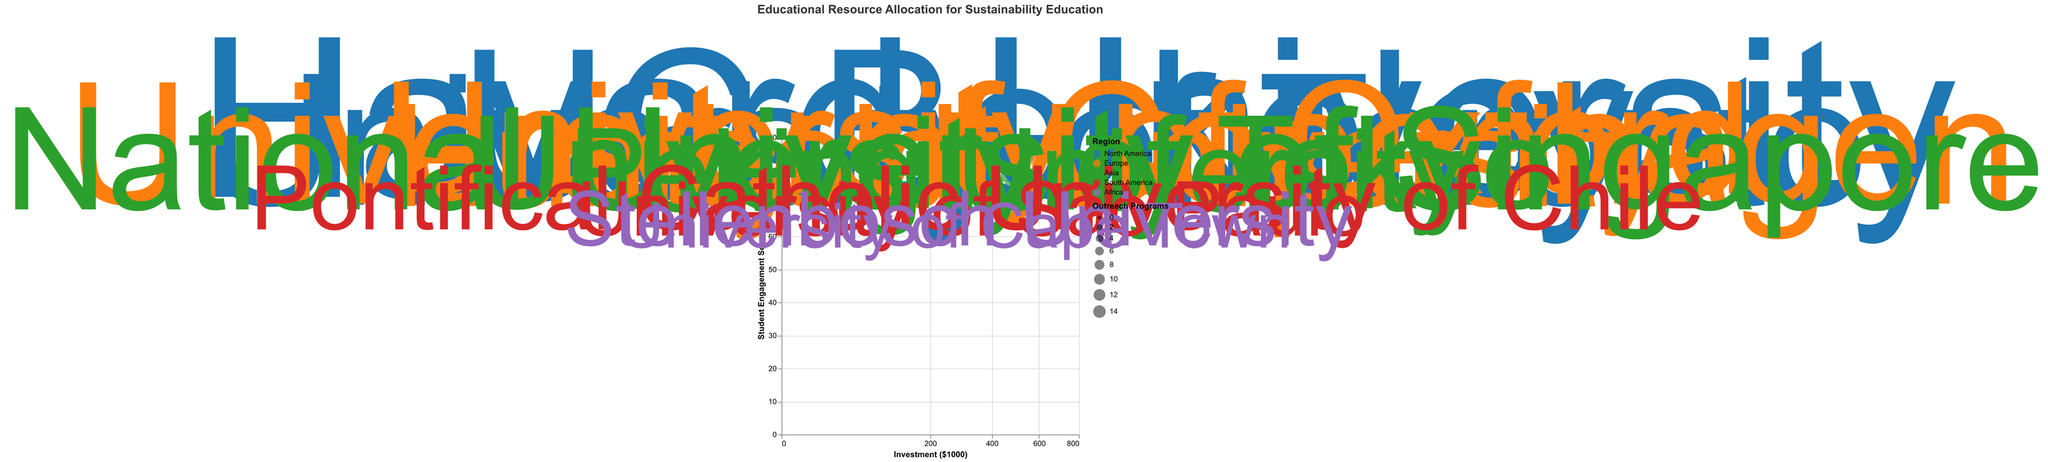What is the title of the figure? The title is usually prominently displayed at the top of the figure. In this case, it should read "Educational Resource Allocation for Sustainability Education."
Answer: Educational Resource Allocation for Sustainability Education How many regions are represented in the chart? The regions are indicated by different colors in the legend. By counting the unique colors for regions such as North America, Europe, Asia, South America, and Africa, we see there are 5 regions.
Answer: 5 Which institute has the highest investment? By looking at the x-axis that shows "Investment ($1000)" and identifying the point furthest to the right, we find that Harvard University has the highest investment at $750,000.
Answer: Harvard University What is the institute with the lowest Student Engagement Score? By examining the y-axis representing "Student Engagement Score," the lowest scoring point is at 60, which corresponds to the University of Cape Town.
Answer: University of Cape Town What is the average Investment ($1000) in Asia? Sum the investments of the universities in Asia and divide by the number of universities: (450 + 470 + 500) / 3 = 1420 / 3 = 473.33.
Answer: 473.33 Which institute has the most Outreach Programs in Europe? Look at the sizes of the data points in Europe. The largest sized point in Europe, representing the University of Oxford, has the most Outreach Programs at 10.
Answer: University of Oxford Is there a correlation between Investment and Student Engagement Score in North America? By examining the data points for North America, we see that as the Investment ($1000) increases, there is a corresponding increase in the Student Engagement Score, indicating a positive correlation.
Answer: Yes Which institute has the smallest size of Outreach Programs and what is its value? The size of each point corresponds to the number of Outreach Programs. The smallest point on the chart corresponds to the University of Cape Town with 3 Outreach Programs.
Answer: University of Cape Town, 3 Compare the Student Engagement Scores between North America and Africa. Which region has a higher overall score? Comparing the scores in North America (84, 90, 88) to Africa (60, 62), we see that North America’s scores are consistently higher. The average scores can confirm this: 87.33 for North America and 61 for Africa.
Answer: North America 